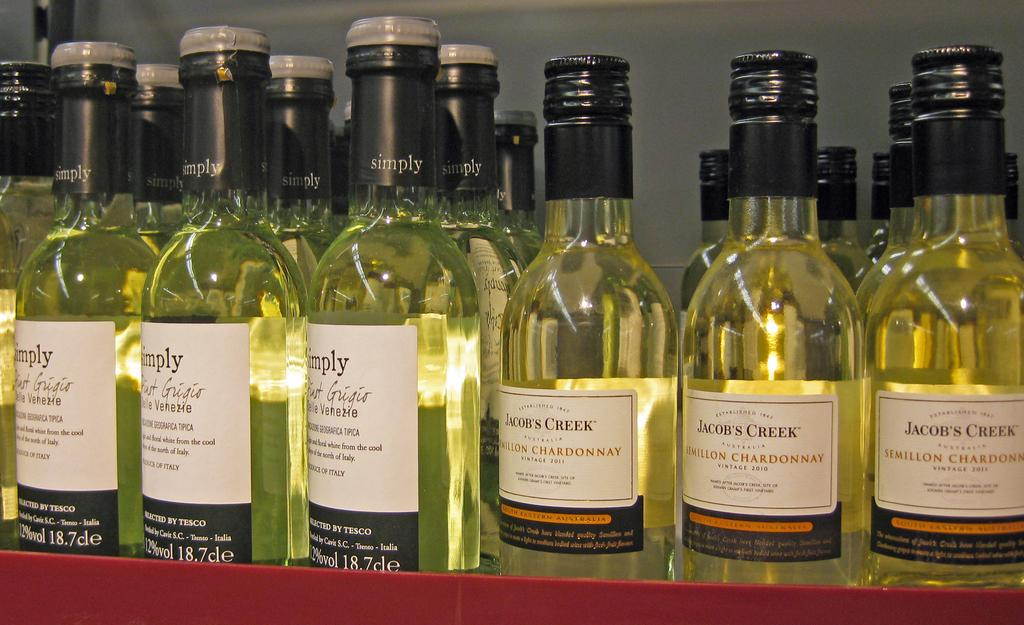<image>
Render a clear and concise summary of the photo. Bottle of Jacobs creek chardonnay wine on a shelf 